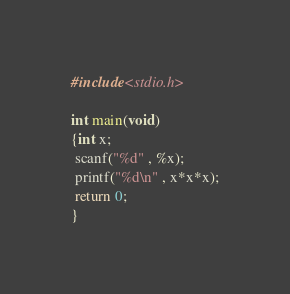<code> <loc_0><loc_0><loc_500><loc_500><_C_>#include<stdio.h>
    
int main(void)
{int x;
 scanf("%d" , %x);
 printf("%d\n" , x*x*x);
 return 0;
}</code> 